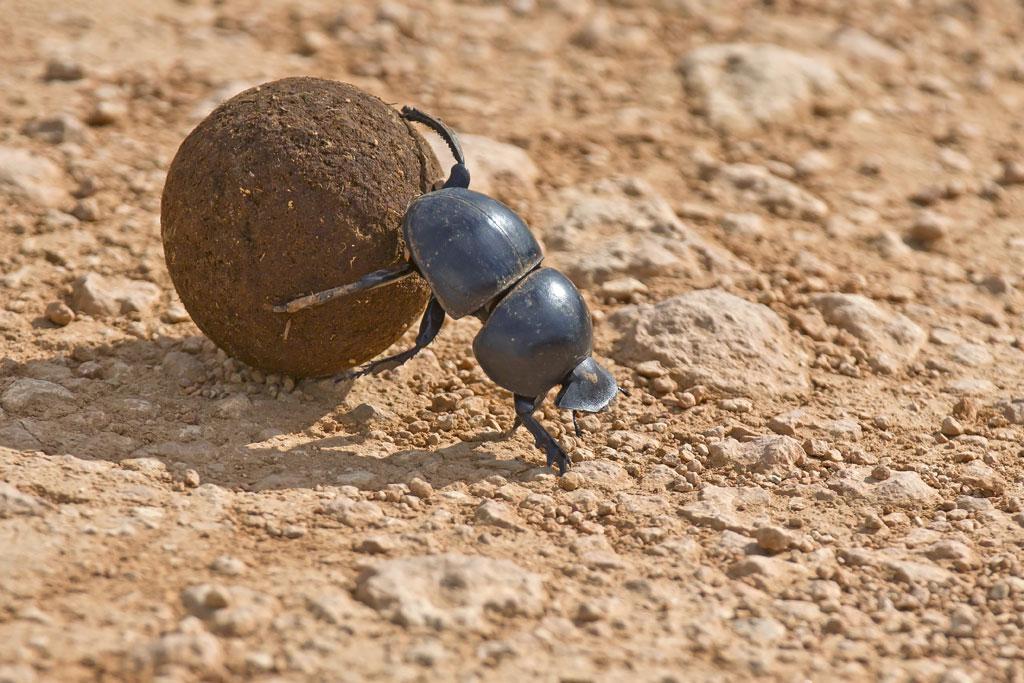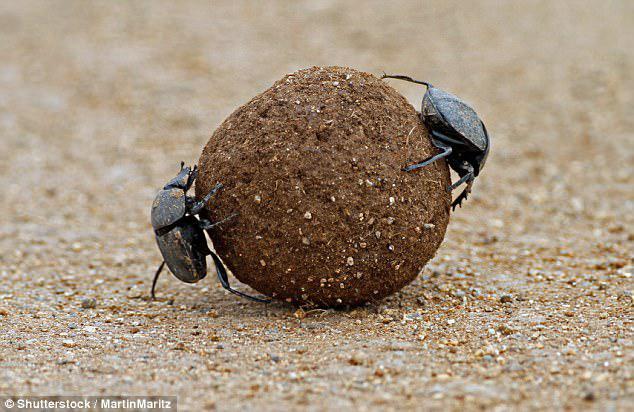The first image is the image on the left, the second image is the image on the right. For the images shown, is this caption "There is a single black beetle in the image on the right." true? Answer yes or no. No. 